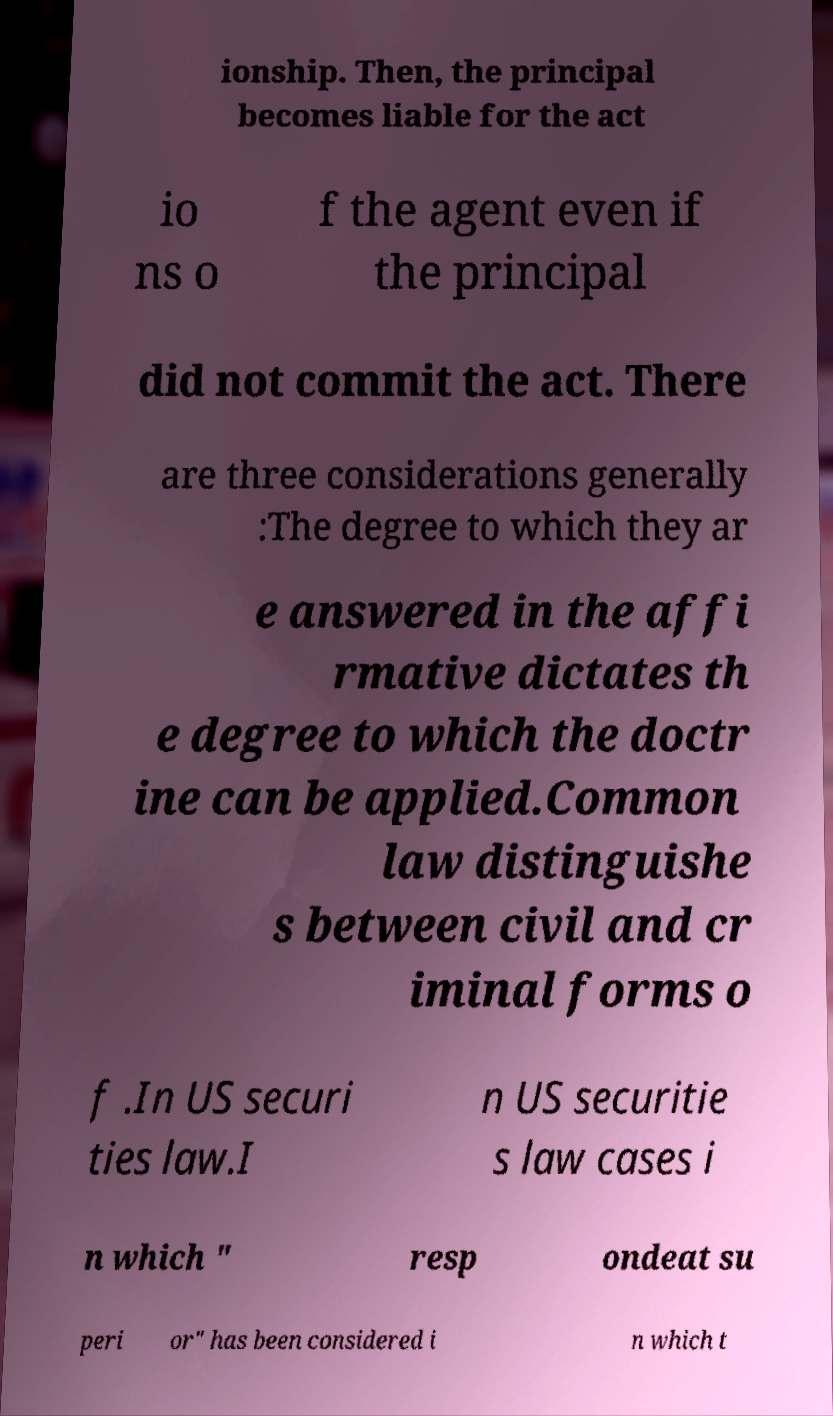What messages or text are displayed in this image? I need them in a readable, typed format. ionship. Then, the principal becomes liable for the act io ns o f the agent even if the principal did not commit the act. There are three considerations generally :The degree to which they ar e answered in the affi rmative dictates th e degree to which the doctr ine can be applied.Common law distinguishe s between civil and cr iminal forms o f .In US securi ties law.I n US securitie s law cases i n which " resp ondeat su peri or" has been considered i n which t 